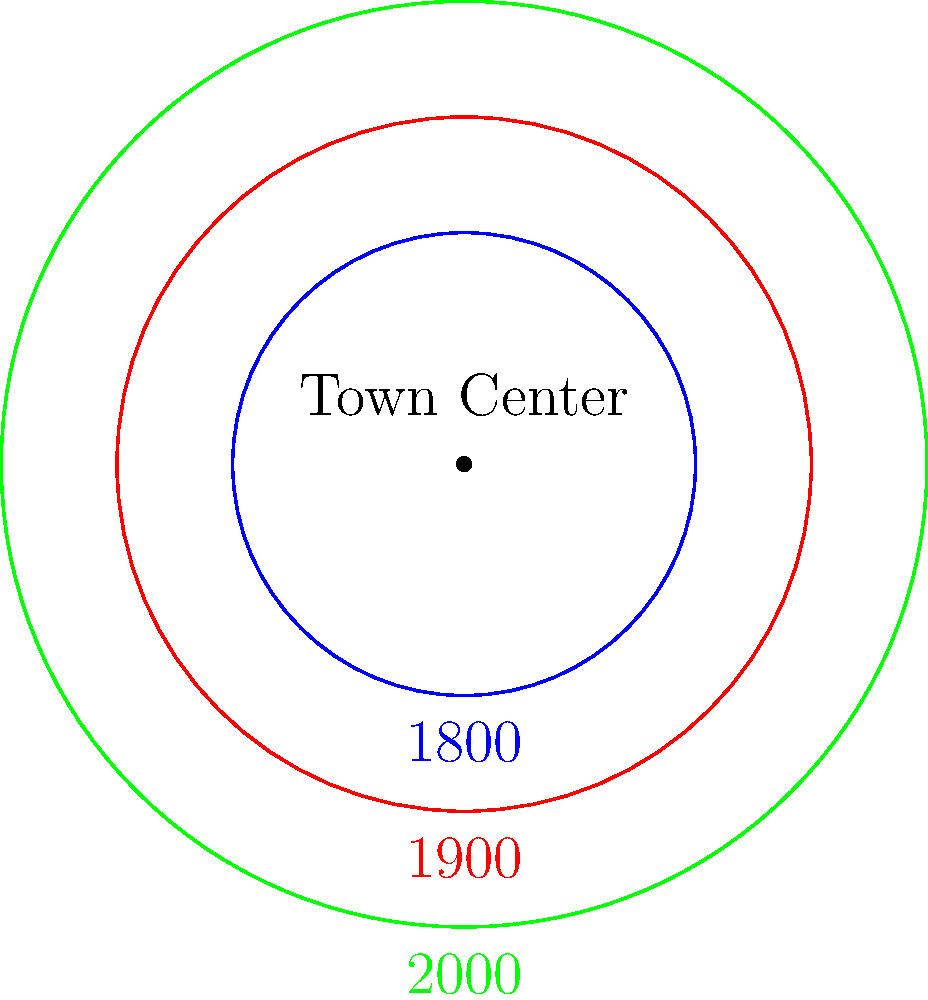Based on the diagram representing Ennis town's historical boundary changes, what shape best describes the town's expansion pattern from 1800 to 2000? To determine the shape of Ennis town's historical boundary changes, let's analyze the diagram step-by-step:

1. The diagram shows three concentric circles representing the town boundaries in different years:
   - Blue circle (innermost): 1800
   - Red circle (middle): 1900
   - Green circle (outermost): 2000

2. All circles are centered on the same point, labeled "Town Center."

3. The circles increase in size from 1800 to 2000, indicating expansion.

4. The expansion is uniform in all directions from the town center.

5. The distance between each circle is approximately equal, suggesting a consistent rate of expansion over time.

6. The circular shape is maintained throughout the expansion process.

Given these observations, the shape that best describes the town's expansion pattern is circular or concentric. The town has grown outward from its center in all directions equally, maintaining its circular shape while increasing in size over time.
Answer: Concentric circular expansion 